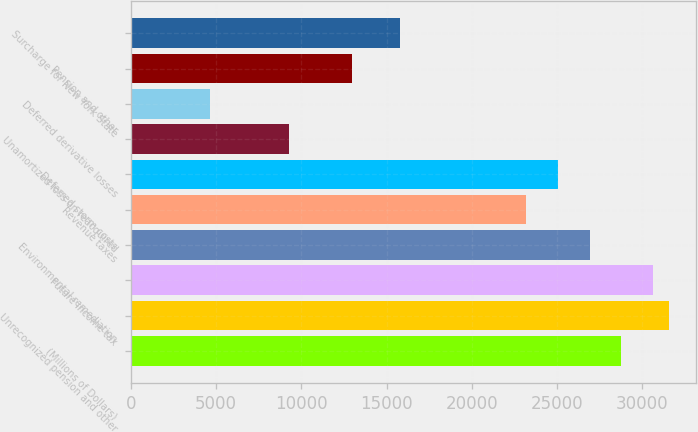Convert chart to OTSL. <chart><loc_0><loc_0><loc_500><loc_500><bar_chart><fcel>(Millions of Dollars)<fcel>Unrecognized pension and other<fcel>Future income tax<fcel>Environmental remediation<fcel>Revenue taxes<fcel>Deferred storm costs<fcel>Unamortized loss on reacquired<fcel>Deferred derivative losses<fcel>Pension and other<fcel>Surcharge for New York State<nl><fcel>28757.5<fcel>31540<fcel>30612.5<fcel>26902.5<fcel>23192.5<fcel>25047.5<fcel>9280<fcel>4642.5<fcel>12990<fcel>15772.5<nl></chart> 